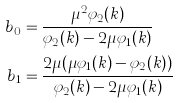<formula> <loc_0><loc_0><loc_500><loc_500>b _ { 0 } & = \frac { \mu ^ { 2 } \varphi _ { 2 } ( k ) } { \varphi _ { 2 } ( k ) - 2 \mu \varphi _ { 1 } ( k ) } \\ b _ { 1 } & = \frac { 2 \mu ( \mu \varphi _ { 1 } ( k ) - \varphi _ { 2 } ( k ) ) } { \varphi _ { 2 } ( k ) - 2 \mu \varphi _ { 1 } ( k ) }</formula> 